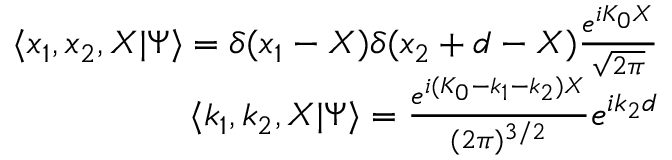<formula> <loc_0><loc_0><loc_500><loc_500>\begin{array} { r } { \langle x _ { 1 } , x _ { 2 } , X | \Psi \rangle = \delta ( x _ { 1 } - X ) \delta ( x _ { 2 } + d - X ) \frac { e ^ { i K _ { 0 } X } } { \sqrt { 2 \pi } } } \\ { \langle k _ { 1 } , k _ { 2 } , X | \Psi \rangle = \frac { e ^ { i ( K _ { 0 } - k _ { 1 } - k _ { 2 } ) X } } { ( 2 \pi ) ^ { 3 / 2 } } e ^ { i k _ { 2 } d } } \end{array}</formula> 